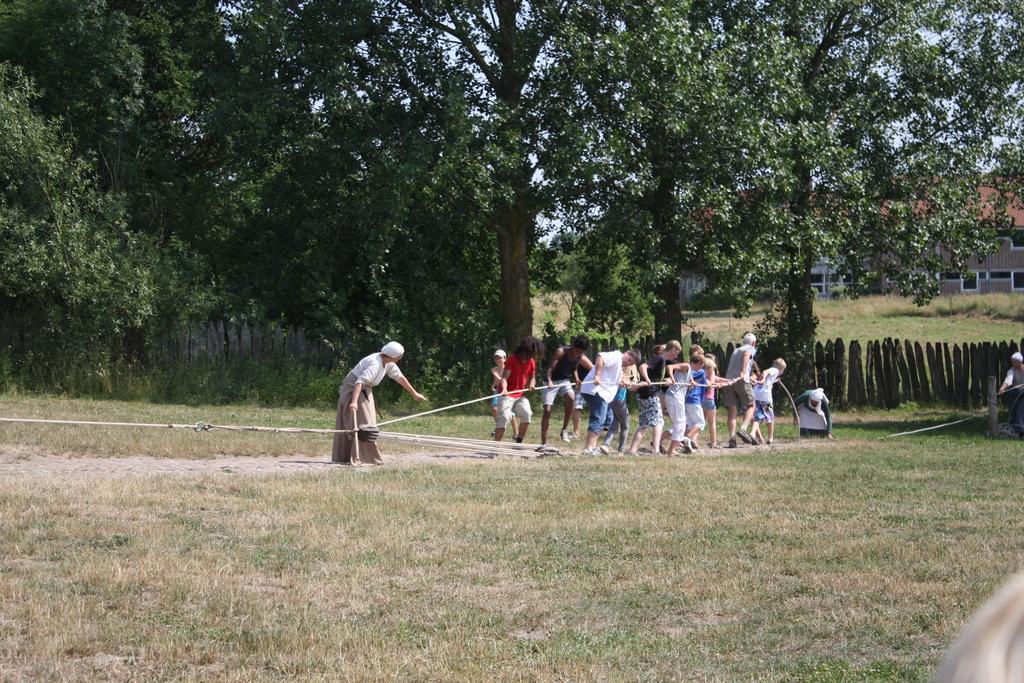In one or two sentences, can you explain what this image depicts? In this image I can see there are few people holding a rope and there is some grass on the floor, there are trees in the background, there is a building on right side and the sky is clear. 